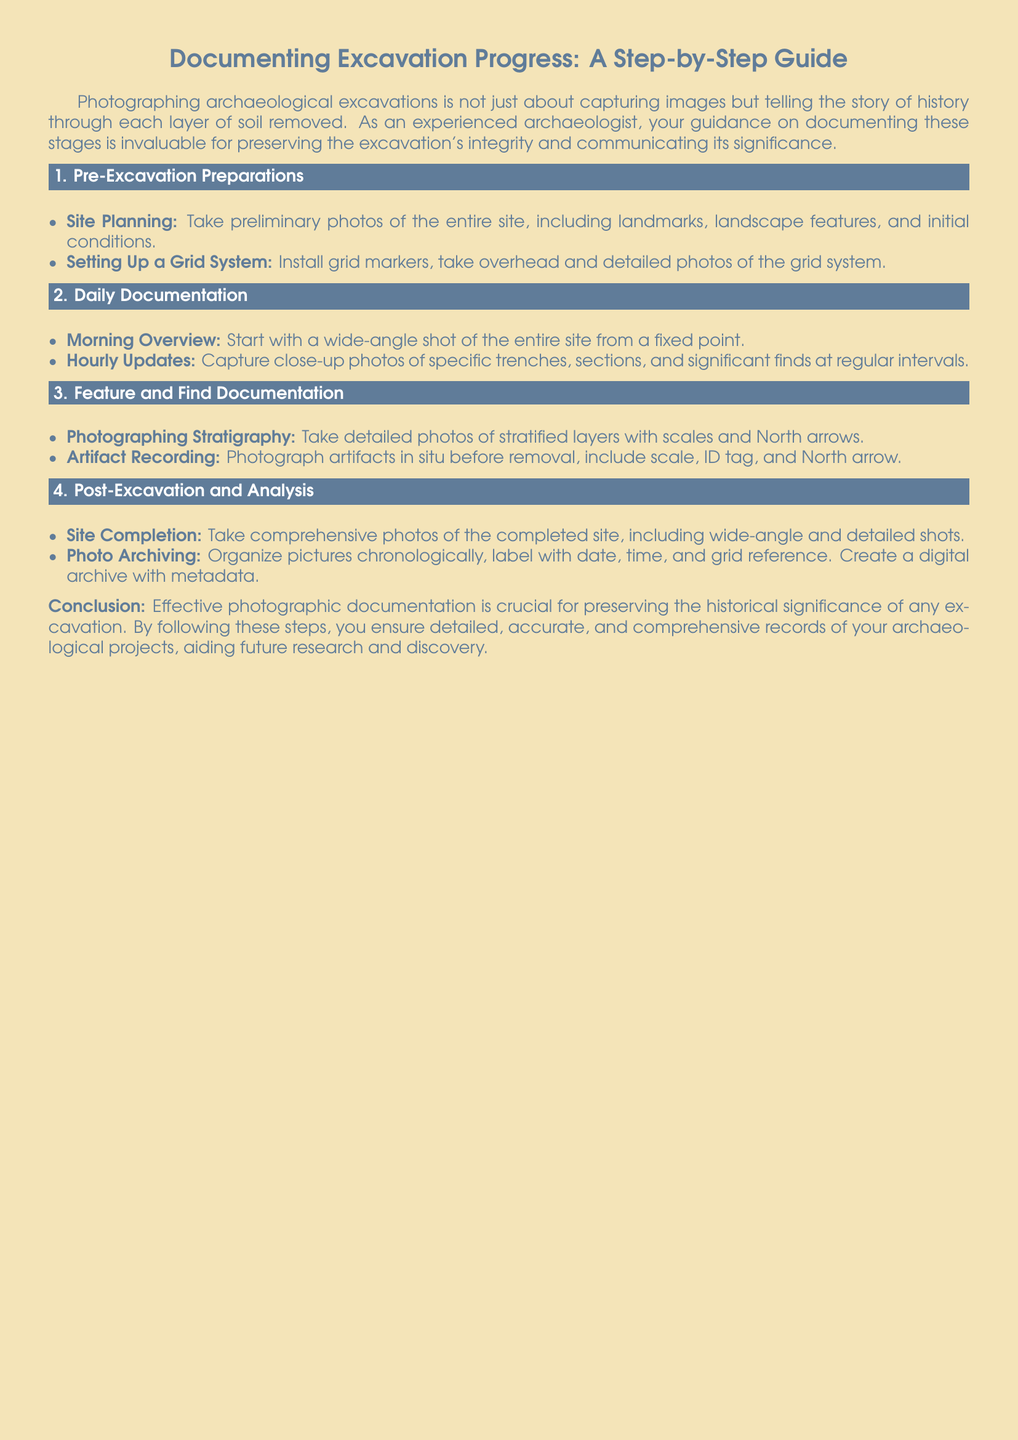What are the two main components required in the pre-excavation preparations section? The document outlines "Site Planning" and "Setting Up a Grid System" as the essential components for pre-excavation preparations.
Answer: Site Planning, Setting Up a Grid System What is the first type of photo to capture on a daily basis? The first type of photo to capture according to the daily documentation is a "Morning Overview," which involves a wide-angle shot of the entire site.
Answer: Morning Overview What should be included when photographing artifacts? The document specifies that photographs of artifacts should include a "scale," "ID tag," and "North arrow."
Answer: scale, ID tag, North arrow How should photos be archived after excavation? The guide indicates that photos should be "organized chronologically," labeled with "date, time, and grid reference," and a digital archive with "metadata" should be created.
Answer: organized chronologically, date, time, grid reference, metadata What does effective photographic documentation preserve? According to the conclusion of the document, effective photographic documentation is crucial for "preserving the historical significance" of an excavation.
Answer: preserving the historical significance 